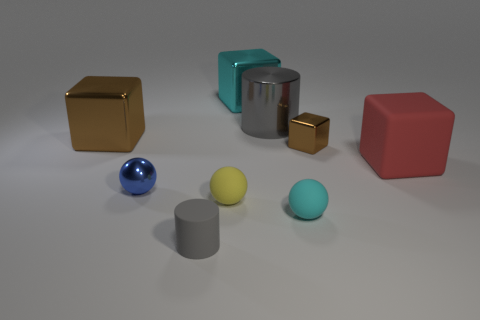What number of other things are there of the same color as the large metal cylinder?
Provide a short and direct response. 1. Are there an equal number of red matte blocks on the right side of the big cyan shiny object and red rubber objects?
Provide a succinct answer. Yes. Do the yellow object and the cyan matte thing have the same size?
Make the answer very short. Yes. There is a thing that is to the left of the big gray metal cylinder and behind the big brown object; what is its material?
Your answer should be compact. Metal. How many other big objects have the same shape as the red thing?
Keep it short and to the point. 2. There is a cylinder that is in front of the yellow ball; what material is it?
Offer a terse response. Rubber. Are there fewer cylinders behind the yellow object than small yellow balls?
Give a very brief answer. No. Is the shape of the tiny cyan object the same as the tiny yellow thing?
Your answer should be compact. Yes. Are there any purple shiny spheres?
Keep it short and to the point. No. There is a large matte object; is its shape the same as the tiny metal thing that is behind the red cube?
Your answer should be compact. Yes. 